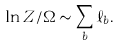Convert formula to latex. <formula><loc_0><loc_0><loc_500><loc_500>\ln Z / \Omega \sim \sum _ { b } \ell _ { b } .</formula> 